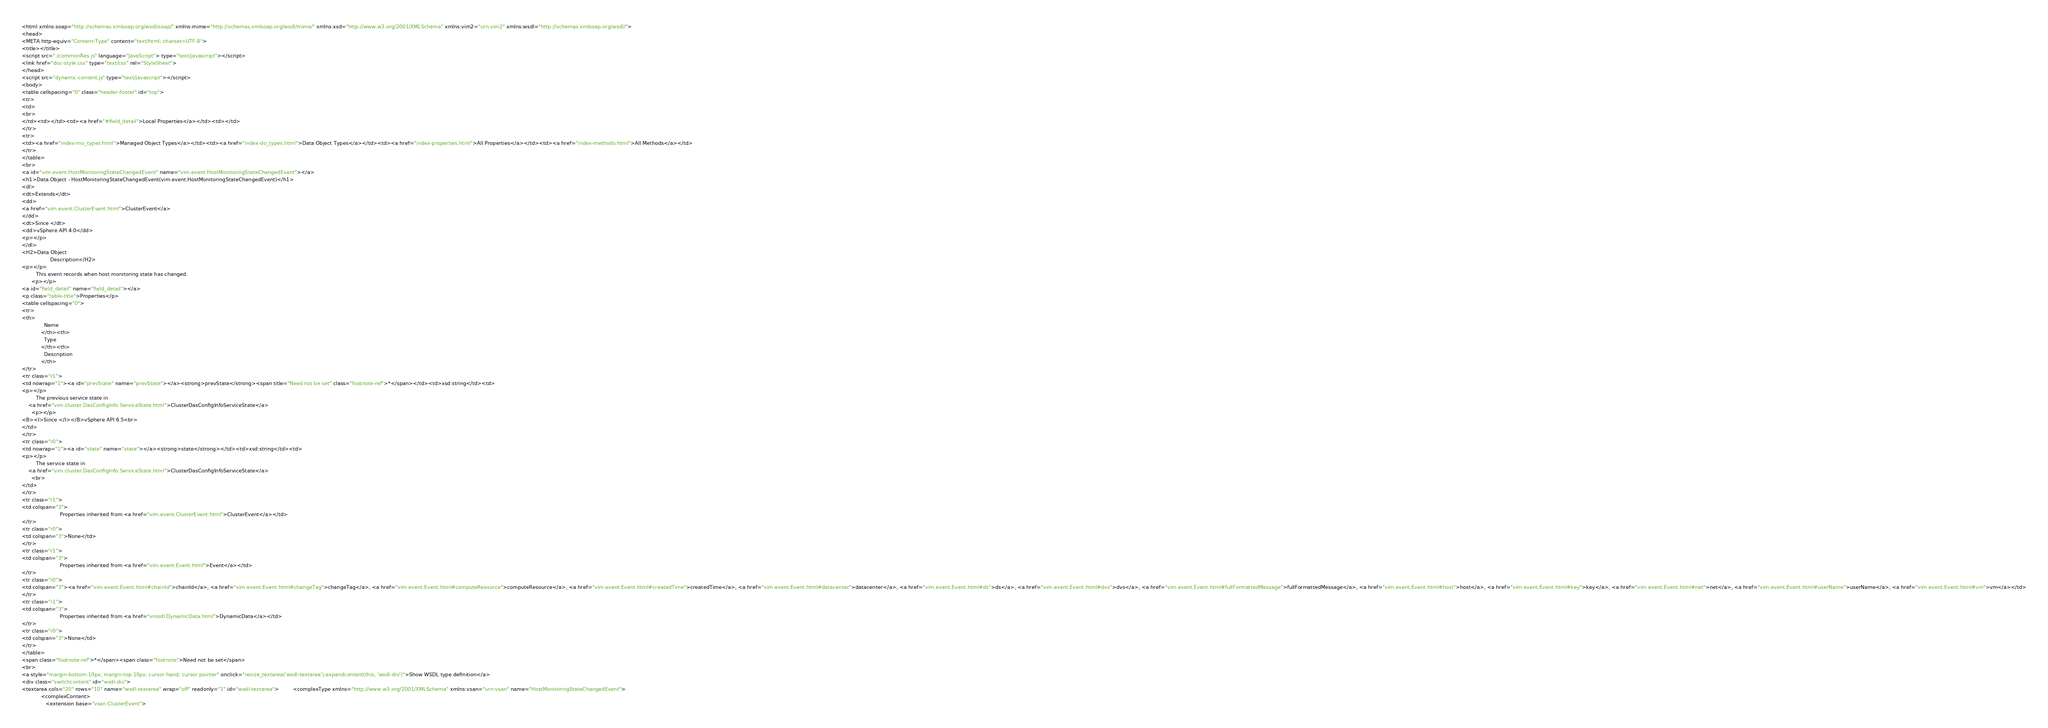Convert code to text. <code><loc_0><loc_0><loc_500><loc_500><_HTML_><html xmlns:soap="http://schemas.xmlsoap.org/wsdl/soap/" xmlns:mime="http://schemas.xmlsoap.org/wsdl/mime/" xmlns:xsd="http://www.w3.org/2001/XMLSchema" xmlns:vim2="urn:vim2" xmlns:wsdl="http://schemas.xmlsoap.org/wsdl/">
<head>
<META http-equiv="Content-Type" content="text/html; charset=UTF-8">
<title></title>
<script src="./commonRes.js" language="JavaScript"> type="text/javascript"></script>
<link href="doc-style.css" type="text/css" rel="StyleSheet">
</head>
<script src="dynamic-content.js" type="text/javascript"></script>
<body>
<table cellspacing="0" class="header-footer" id="top">
<tr>
<td>
<br>
</td><td></td><td><a href="#field_detail">Local Properties</a></td><td></td>
</tr>
<tr>
<td><a href="index-mo_types.html">Managed Object Types</a></td><td><a href="index-do_types.html">Data Object Types</a></td><td><a href="index-properties.html">All Properties</a></td><td><a href="index-methods.html">All Methods</a></td>
</tr>
</table>
<br>
<a id="vim.event.HostMonitoringStateChangedEvent" name="vim.event.HostMonitoringStateChangedEvent"></a>
<h1>Data Object - HostMonitoringStateChangedEvent(vim.event.HostMonitoringStateChangedEvent)</h1>
<dl>
<dt>Extends</dt>
<dd>
<a href="vim.event.ClusterEvent.html">ClusterEvent</a>
</dd>
<dt>Since </dt>
<dd>vSphere API 4.0</dd>
<p></p>
</dl>
<H2>Data Object 
                  Description</H2>
<p></p>
         This event records when host monitoring state has changed.
      <p></p>
<a id="field_detail" name="field_detail"></a>
<p class="table-title">Properties</p>
<table cellspacing="0">
<tr>
<th>
	          Name
	        </th><th>
	          Type
	        </th><th>
	          Description
	        </th>
</tr>
<tr class="r1">
<td nowrap="1"><a id="prevState" name="prevState"></a><strong>prevState</strong><span title="Need not be set" class="footnote-ref">*</span></td><td>xsd:string</td><td>
<p></p>
         The previous service state in
    <a href="vim.cluster.DasConfigInfo.ServiceState.html">ClusterDasConfigInfoServiceState</a>
      <p></p>
<B><I>Since </I></B>vSphere API 6.5<br>
</td>
</tr>
<tr class="r0">
<td nowrap="1"><a id="state" name="state"></a><strong>state</strong></td><td>xsd:string</td><td>
<p></p>
         The service state in
    <a href="vim.cluster.DasConfigInfo.ServiceState.html">ClusterDasConfigInfoServiceState</a>
      <br>
</td>
</tr>
<tr class="r1">
<td colspan="3">
						Properties inherited from <a href="vim.event.ClusterEvent.html">ClusterEvent</a></td>
</tr>
<tr class="r0">
<td colspan="3">None</td>
</tr>
<tr class="r1">
<td colspan="3">
						Properties inherited from <a href="vim.event.Event.html">Event</a></td>
</tr>
<tr class="r0">
<td colspan="3"><a href="vim.event.Event.html#chainId">chainId</a>, <a href="vim.event.Event.html#changeTag">changeTag</a>, <a href="vim.event.Event.html#computeResource">computeResource</a>, <a href="vim.event.Event.html#createdTime">createdTime</a>, <a href="vim.event.Event.html#datacenter">datacenter</a>, <a href="vim.event.Event.html#ds">ds</a>, <a href="vim.event.Event.html#dvs">dvs</a>, <a href="vim.event.Event.html#fullFormattedMessage">fullFormattedMessage</a>, <a href="vim.event.Event.html#host">host</a>, <a href="vim.event.Event.html#key">key</a>, <a href="vim.event.Event.html#net">net</a>, <a href="vim.event.Event.html#userName">userName</a>, <a href="vim.event.Event.html#vm">vm</a></td>
</tr>
<tr class="r1">
<td colspan="3">
						Properties inherited from <a href="vmodl.DynamicData.html">DynamicData</a></td>
</tr>
<tr class="r0">
<td colspan="3">None</td>
</tr>
</table>
<span class="footnote-ref">*</span><span class="footnote">Need not be set</span>
<br>
<a style="margin-bottom:10px; margin-top:10px; cursor:hand; cursor:pointer" onclick="resize_textarea('wsdl-textarea');expandcontent(this, 'wsdl-div')">Show WSDL type definition</a>
<div class="switchcontent" id="wsdl-div">
<textarea cols="20" rows="10" name="wsdl-textarea" wrap="off" readonly="1" id="wsdl-textarea">         <complexType xmlns="http://www.w3.org/2001/XMLSchema" xmlns:vsan="urn:vsan" name="HostMonitoringStateChangedEvent">
            <complexContent>
               <extension base="vsan:ClusterEvent"></code> 